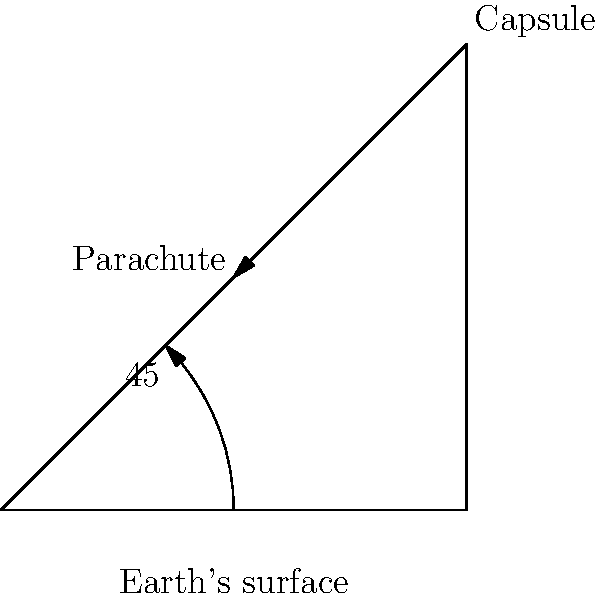During a capsule landing, the optimal angle for deploying the parachute is crucial for a safe descent. Given that the capsule is at an altitude of 100 km and needs to land 100 km away horizontally, what is the optimal angle (in degrees) for parachute deployment to ensure a smooth trajectory towards the landing site? To solve this problem, we need to follow these steps:

1) The capsule's position and the landing site form a right-angled triangle with the Earth's surface.

2) The altitude (100 km) represents the vertical side of this triangle, while the horizontal distance to the landing site (100 km) represents the base.

3) We need to find the angle between the hypotenuse (the optimal trajectory) and the horizontal base.

4) This can be calculated using the arctangent function:

   $$\theta = \arctan(\frac{\text{opposite}}{\text{adjacent}})$$

5) In this case:
   $$\theta = \arctan(\frac{100}{100}) = \arctan(1)$$

6) The arctangent of 1 is equal to 45 degrees.

7) Therefore, the optimal angle for parachute deployment is 45 degrees.

This angle ensures an equal ratio of vertical to horizontal movement, which is ideal for a smooth descent trajectory in this scenario.
Answer: 45° 